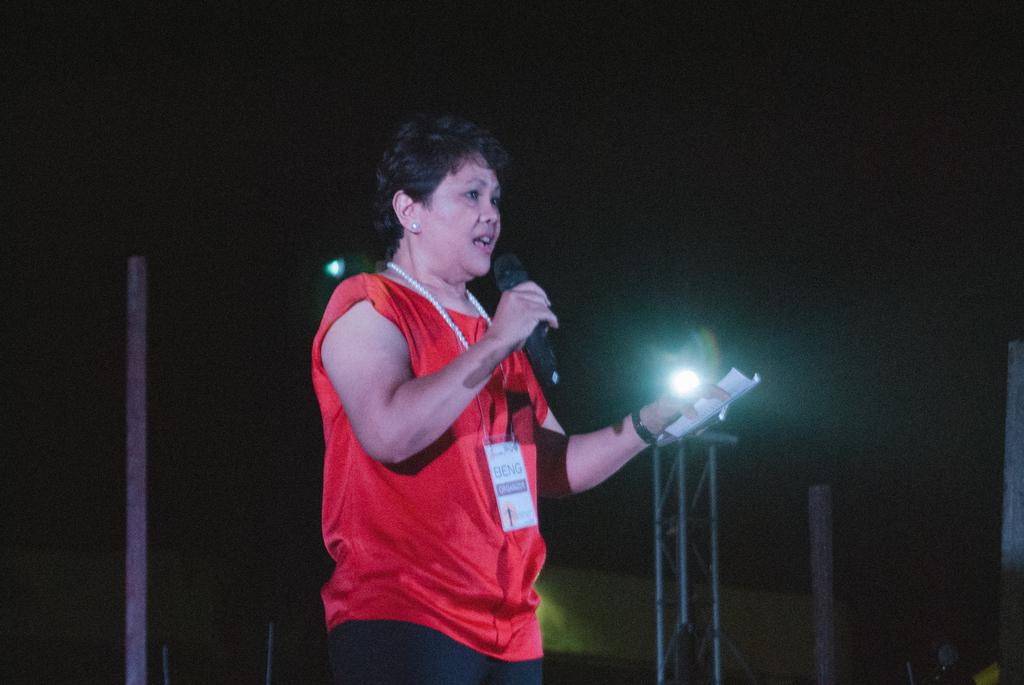Who is the main subject in the image? There is a woman in the image. Where is the woman located in the image? The woman is in the middle of the image. What is the woman holding in her hand? The woman is holding a mic in her hand. What can be observed about the background of the image? The background of the image is dark. What type of mine is visible in the background of the image? There is no mine visible in the background of the image; it features a woman holding a mic in a dark setting. 